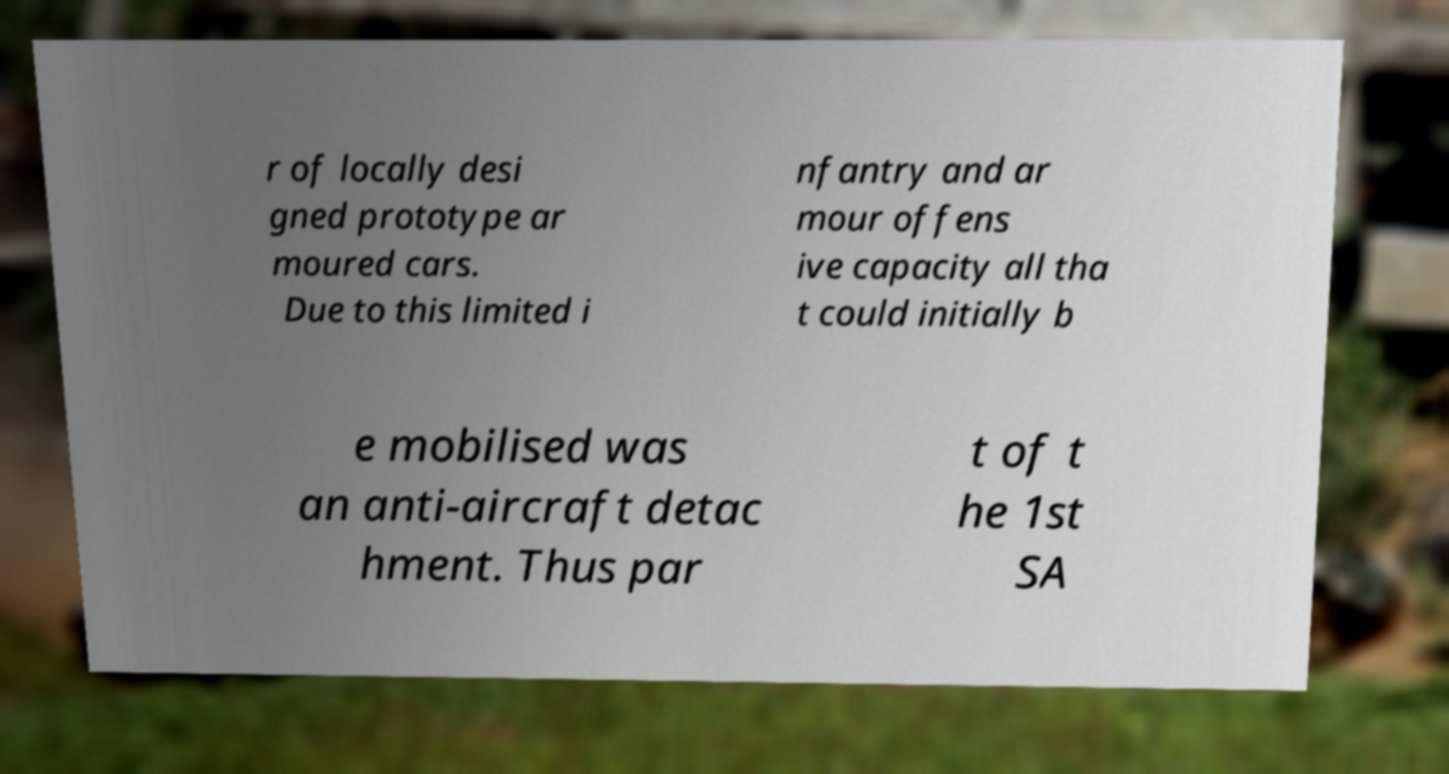What messages or text are displayed in this image? I need them in a readable, typed format. r of locally desi gned prototype ar moured cars. Due to this limited i nfantry and ar mour offens ive capacity all tha t could initially b e mobilised was an anti-aircraft detac hment. Thus par t of t he 1st SA 